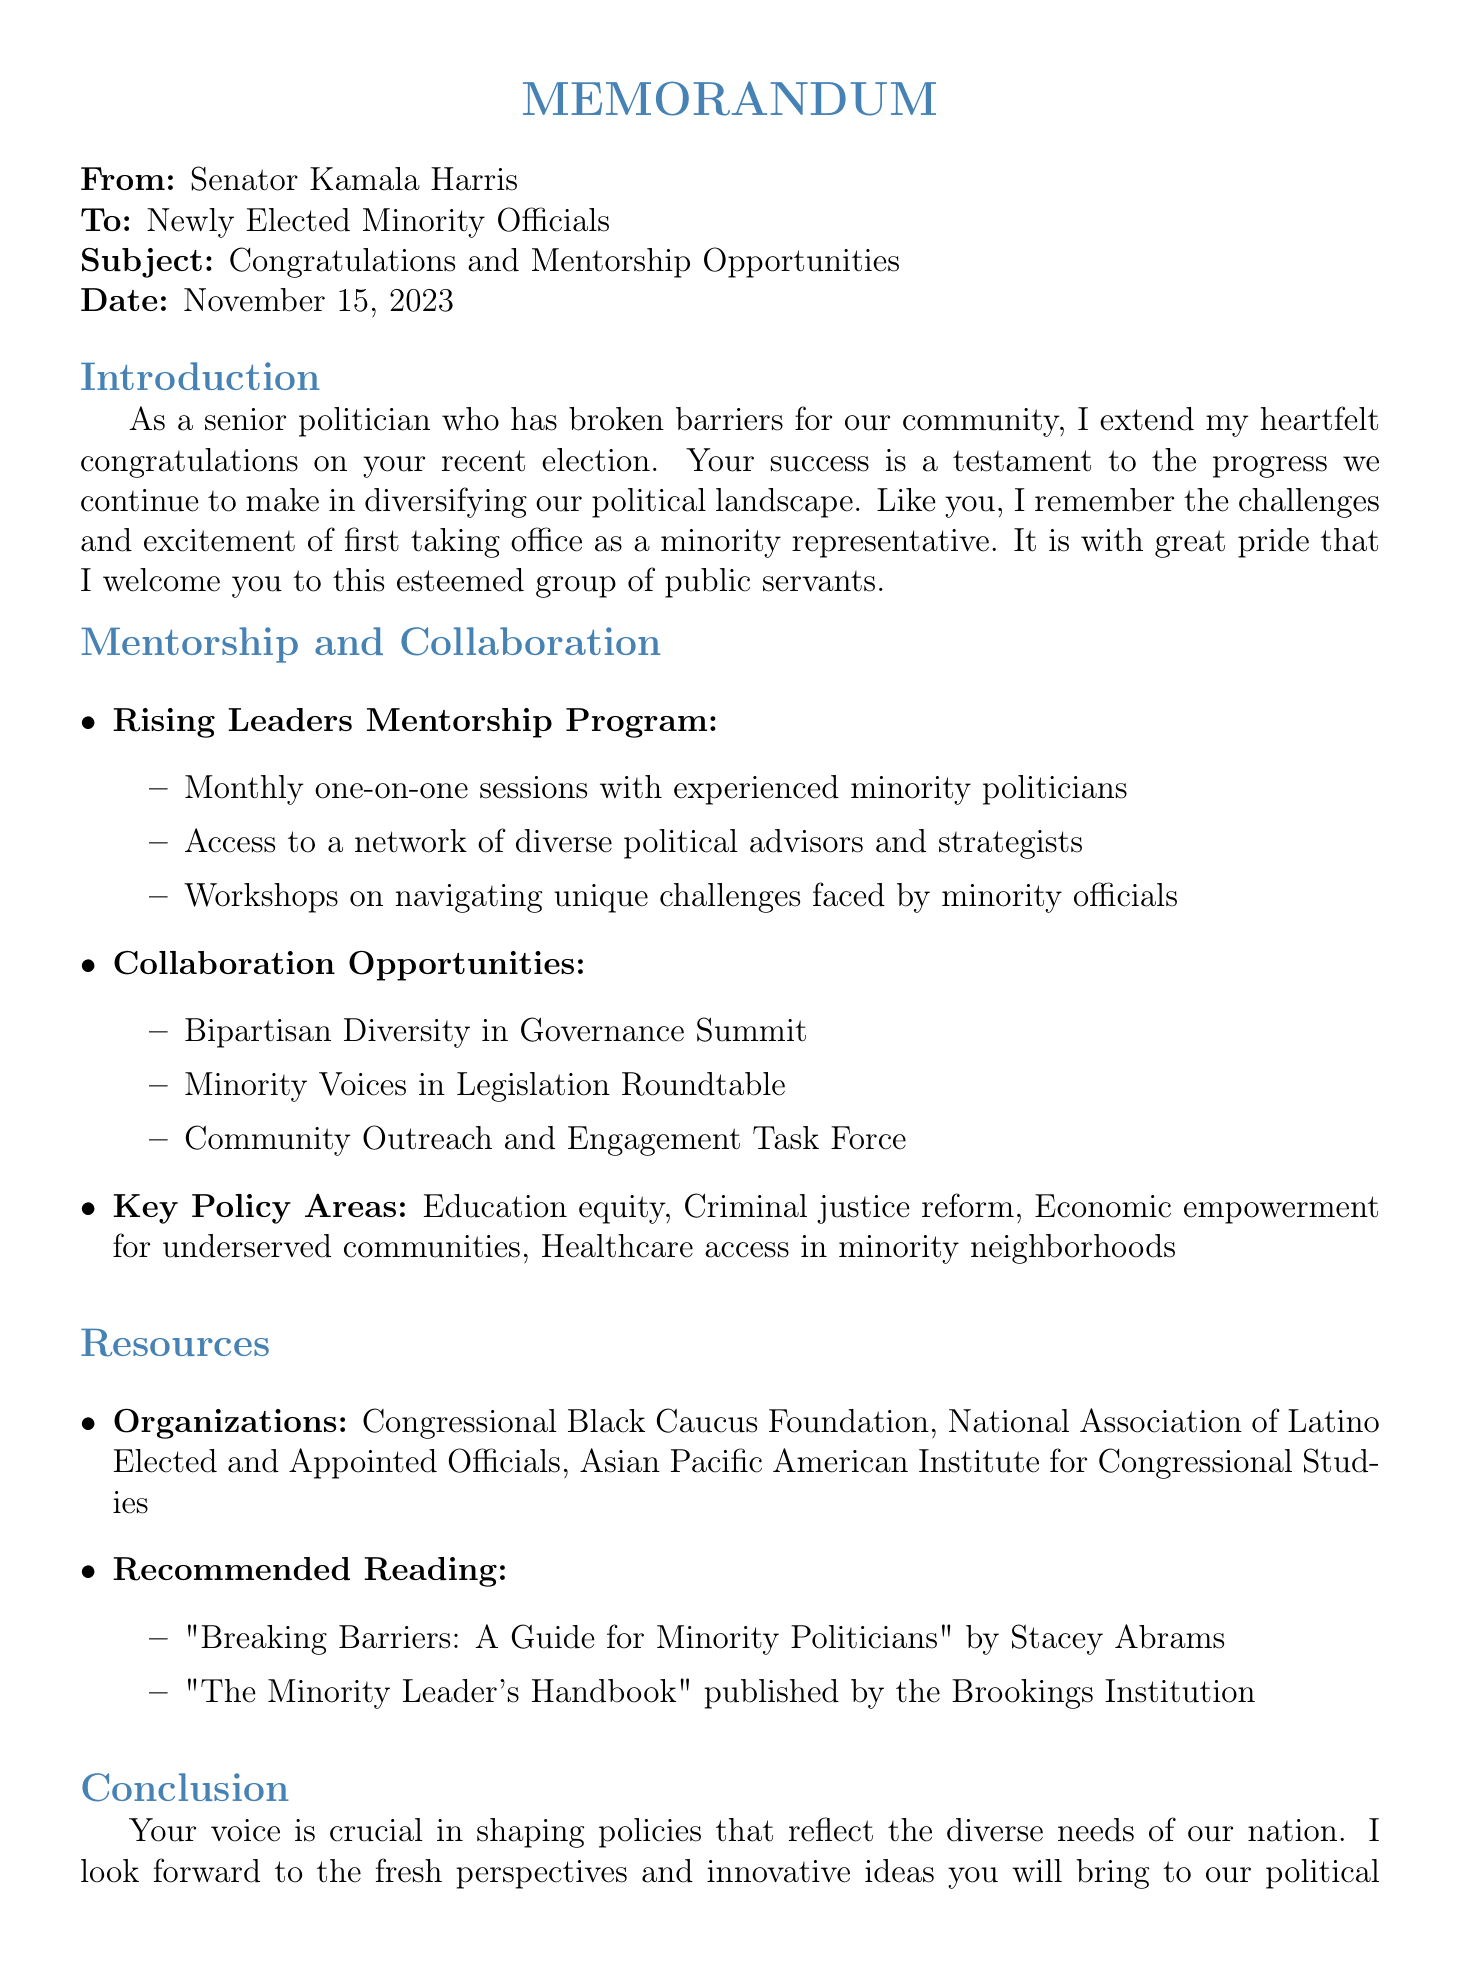What is the date of the memo? The date of the memo is stated at the beginning of the document.
Answer: November 15, 2023 Who is the sender of the memo? The sender of the memo is indicated in the header section.
Answer: Senator Kamala Harris What program is being offered in the memo? The memo mentions a specific mentorship program aimed at supporting newly elected minority officials.
Answer: Rising Leaders Mentorship Program What are the three key areas of collaboration opportunities mentioned? The memo lists initiatives for collaboration under specific headings.
Answer: Bipartisan Diversity in Governance Summit, Minority Voices in Legislation Roundtable, Community Outreach and Engagement Task Force How many monthly sessions are offered in the mentorship program? The document specifies the frequency of the sessions in the mentorship program description.
Answer: Monthly one-on-one sessions What is one of the recommended readings listed in the resources section? The resources section includes publications that are suggested for minority politicians.
Answer: "Breaking Barriers: A Guide for Minority Politicians" by Stacey Abrams What is emphasized as crucial in the conclusion? The conclusion contains a statement regarding the impact of minority officials.
Answer: Voice What is the contact email for mentorship inquiries? The conclusion provides information on how to reach out for further engagements.
Answer: minoritymentorship@senate.gov 